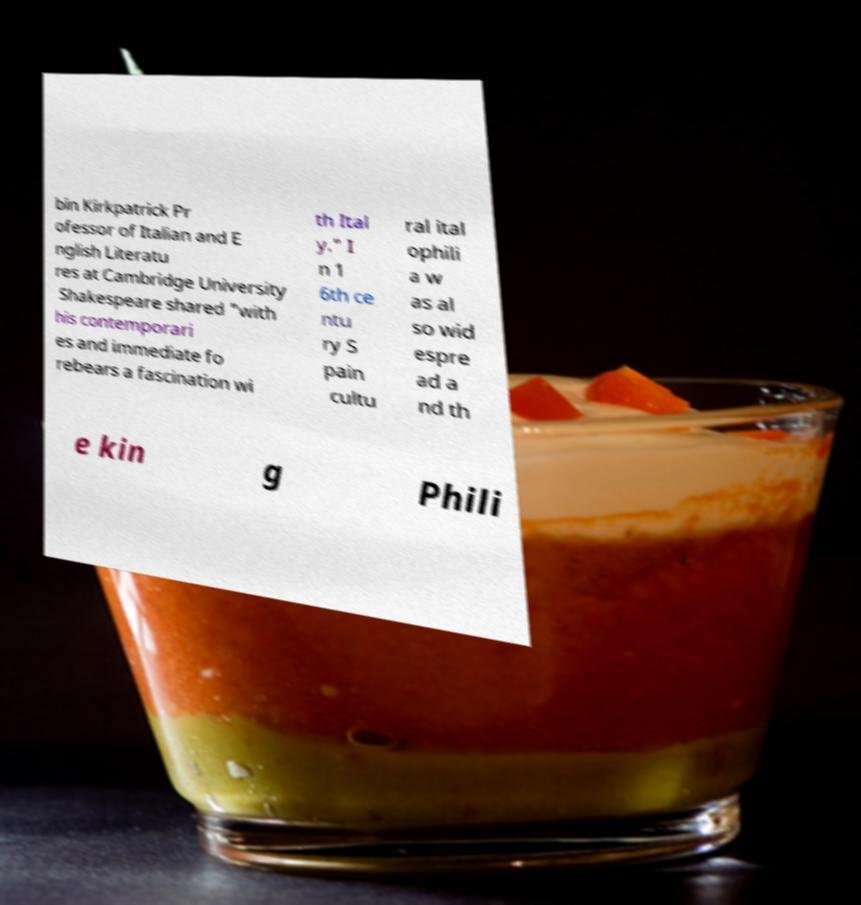For documentation purposes, I need the text within this image transcribed. Could you provide that? bin Kirkpatrick Pr ofessor of Italian and E nglish Literatu res at Cambridge University Shakespeare shared "with his contemporari es and immediate fo rebears a fascination wi th Ital y." I n 1 6th ce ntu ry S pain cultu ral ital ophili a w as al so wid espre ad a nd th e kin g Phili 